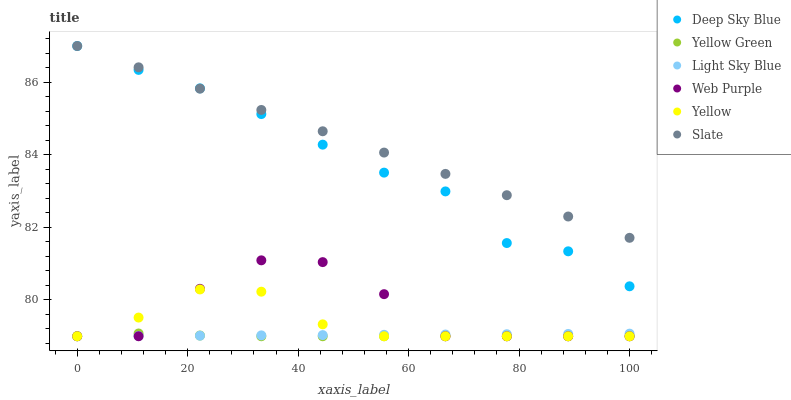Does Yellow Green have the minimum area under the curve?
Answer yes or no. Yes. Does Slate have the maximum area under the curve?
Answer yes or no. Yes. Does Yellow have the minimum area under the curve?
Answer yes or no. No. Does Yellow have the maximum area under the curve?
Answer yes or no. No. Is Light Sky Blue the smoothest?
Answer yes or no. Yes. Is Web Purple the roughest?
Answer yes or no. Yes. Is Slate the smoothest?
Answer yes or no. No. Is Slate the roughest?
Answer yes or no. No. Does Yellow Green have the lowest value?
Answer yes or no. Yes. Does Slate have the lowest value?
Answer yes or no. No. Does Deep Sky Blue have the highest value?
Answer yes or no. Yes. Does Yellow have the highest value?
Answer yes or no. No. Is Yellow less than Deep Sky Blue?
Answer yes or no. Yes. Is Deep Sky Blue greater than Web Purple?
Answer yes or no. Yes. Does Light Sky Blue intersect Yellow?
Answer yes or no. Yes. Is Light Sky Blue less than Yellow?
Answer yes or no. No. Is Light Sky Blue greater than Yellow?
Answer yes or no. No. Does Yellow intersect Deep Sky Blue?
Answer yes or no. No. 